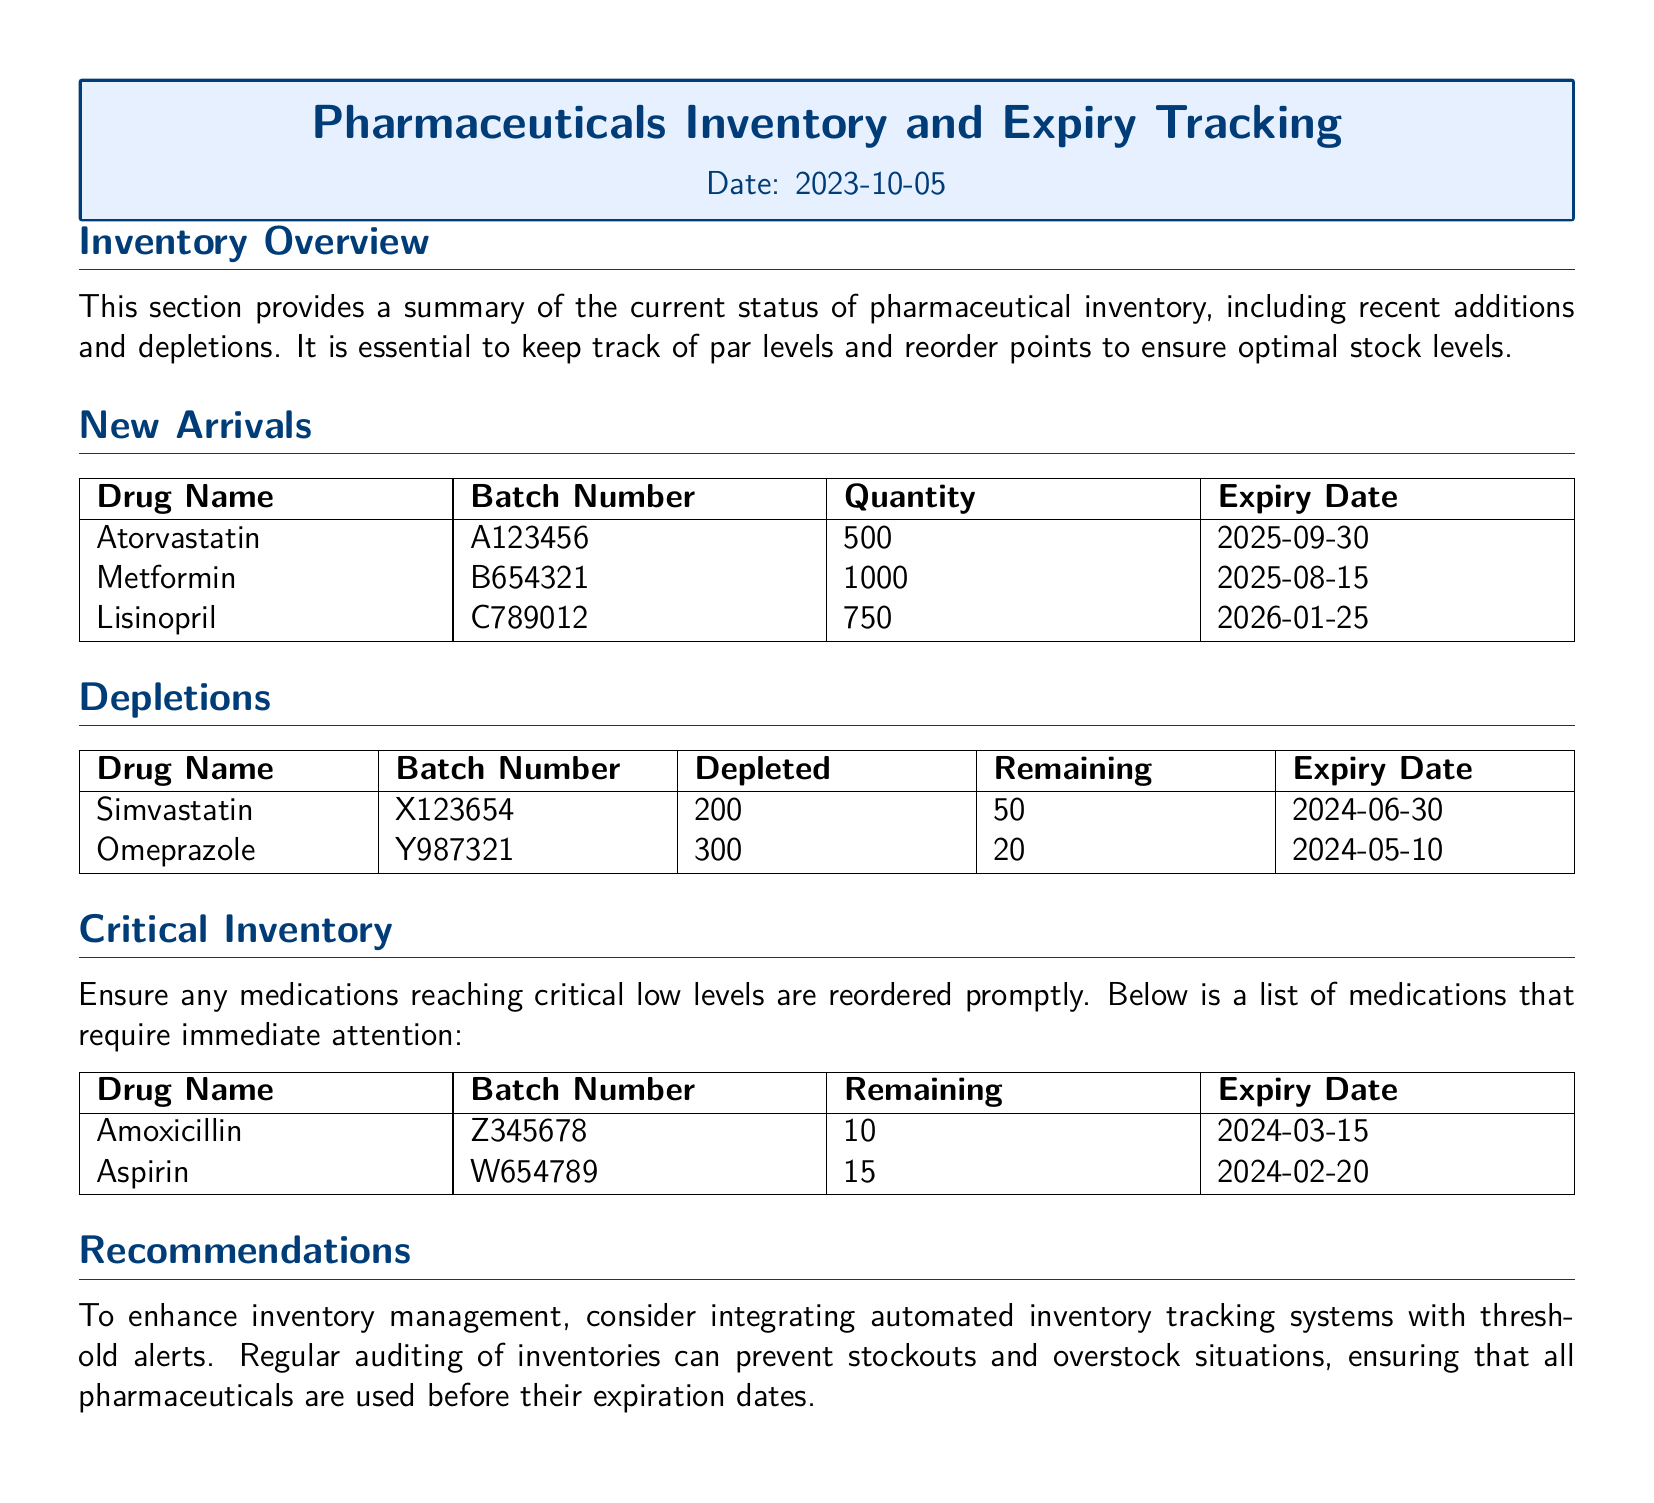What is the date of the report? The date of the report is located at the top of the document.
Answer: 2023-10-05 How many new arrivals are listed in the document? The number of new arrivals is determined from the "New Arrivals" section.
Answer: 3 What is the expiry date of Lisinopril? The expiry date for Lisinopril is found in the "New Arrivals" table.
Answer: 2026-01-25 What is the remaining quantity of Omeprazole? The remaining quantity is noted in the "Depletions" section.
Answer: 20 Which drug is critical in inventory with only 10 remaining? The critical inventory section indicates the drug with low levels.
Answer: Amoxicillin How many units of Simvastatin have been depleted? The amount depleted is specified in the "Depletions" section.
Answer: 200 What is the total number of new arrivals? The total counts of items in the "New Arrivals" section give this information.
Answer: 3 Which medication is recommended for immediate reorder? The "Critical Inventory" section indicates medications needing reorder.
Answer: Amoxicillin What type of system is recommended for inventory management? Recommendations suggest a specific type of system based on the contents of the document.
Answer: Automated inventory tracking systems 